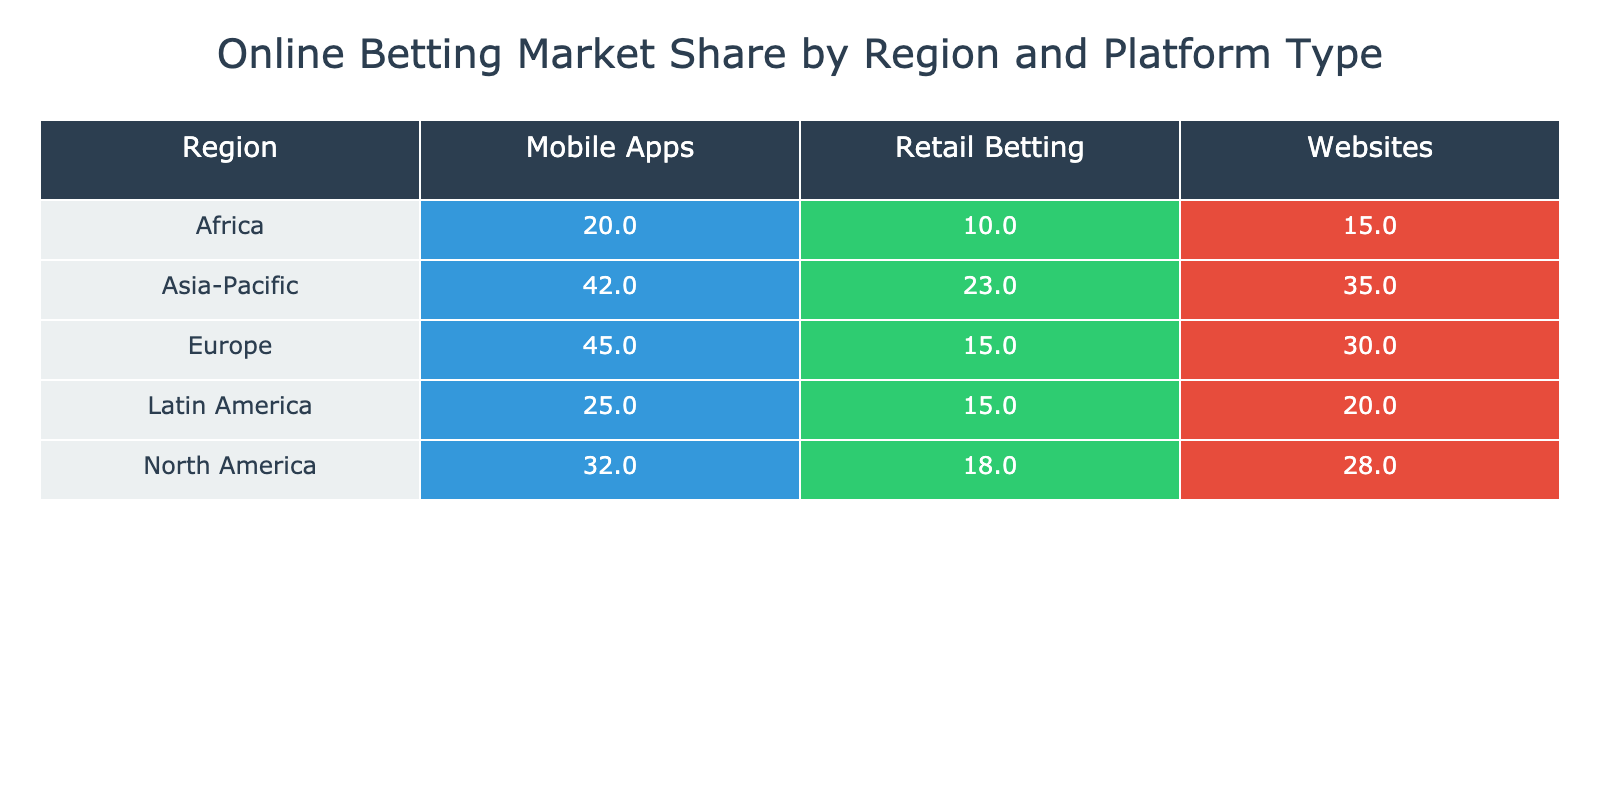What is the market share of mobile apps in North America? According to the table, the market share for mobile apps specifically in North America is listed as 32%.
Answer: 32% Which platform type has the highest market share in Europe? From the table, Europe's market shares indicate that mobile apps have the highest share at 45%.
Answer: Mobile Apps What is the combined market share of websites in Asia-Pacific and Latin America? By looking at the table, the market share of websites in Asia-Pacific is 35% and in Latin America is 20%. Adding these together gives us 35% + 20% = 55%.
Answer: 55% Is the market share for retail betting greater than 20% in any region? Examining the table reveals that the retail betting market share is 23% in Asia-Pacific, which is above 20%. Therefore, the answer is yes.
Answer: Yes Which region has the lowest market share for retail betting? The table shows that Africa has the lowest market share for retail betting at only 10%.
Answer: Africa What is the difference in market share of mobile apps between North America and Asia-Pacific? The market share for mobile apps in North America is 32%, and in Asia-Pacific, it is 42%. The difference is calculated as 42% - 32% = 10%.
Answer: 10% What is the average market share for websites across all regions? The website market shares from the table are 28% (North America), 30% (Europe), 35% (Asia-Pacific), 20% (Latin America), 15% (Africa). The average is calculated by summing these values (28 + 30 + 35 + 20 + 15) = 128 and dividing by 5, which results in 128 / 5 = 25.6%.
Answer: 25.6% Are mobile apps more popular than websites in the Asia-Pacific region? The table indicates that mobile apps have a market share of 42% while websites have a market share of 35%. Since 42% is greater than 35%, the answer is yes.
Answer: Yes What is the market share for retail betting in Europe compared to Latin America? In Europe, the market share for retail betting is 15%, while in Latin America, it is 15% as well. Since both values are equal, we conclude that they have the same market share for retail betting.
Answer: Equal 